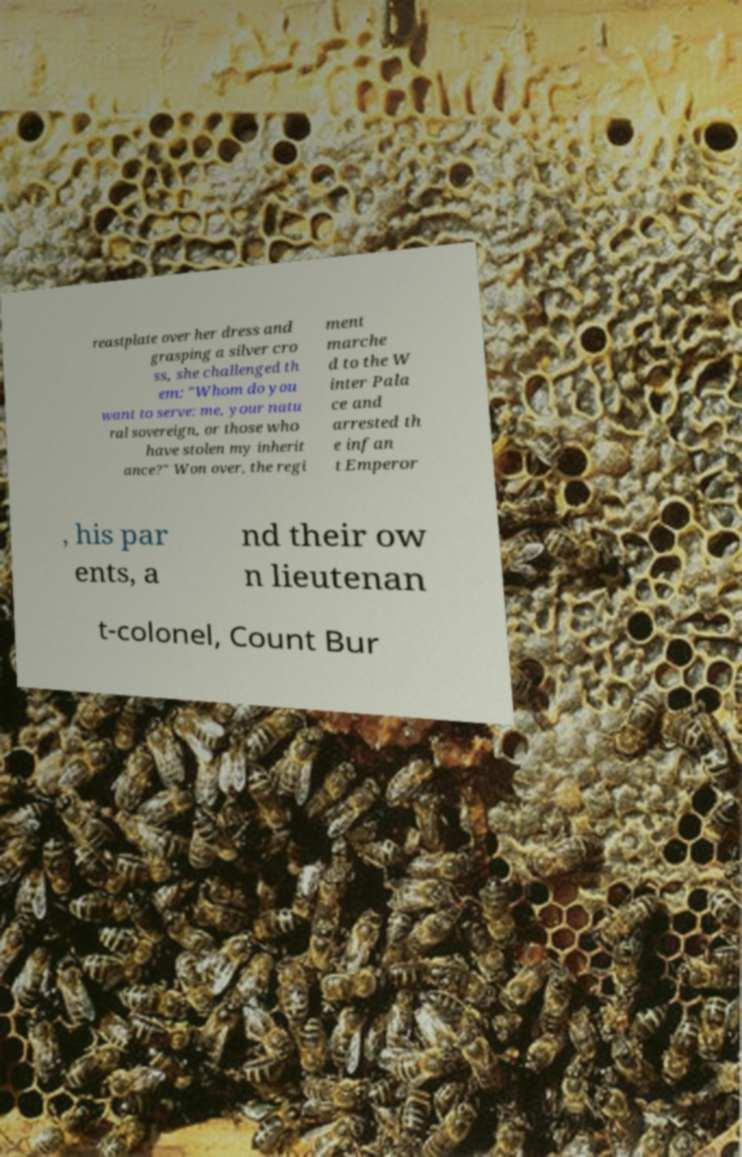Can you accurately transcribe the text from the provided image for me? reastplate over her dress and grasping a silver cro ss, she challenged th em: "Whom do you want to serve: me, your natu ral sovereign, or those who have stolen my inherit ance?" Won over, the regi ment marche d to the W inter Pala ce and arrested th e infan t Emperor , his par ents, a nd their ow n lieutenan t-colonel, Count Bur 